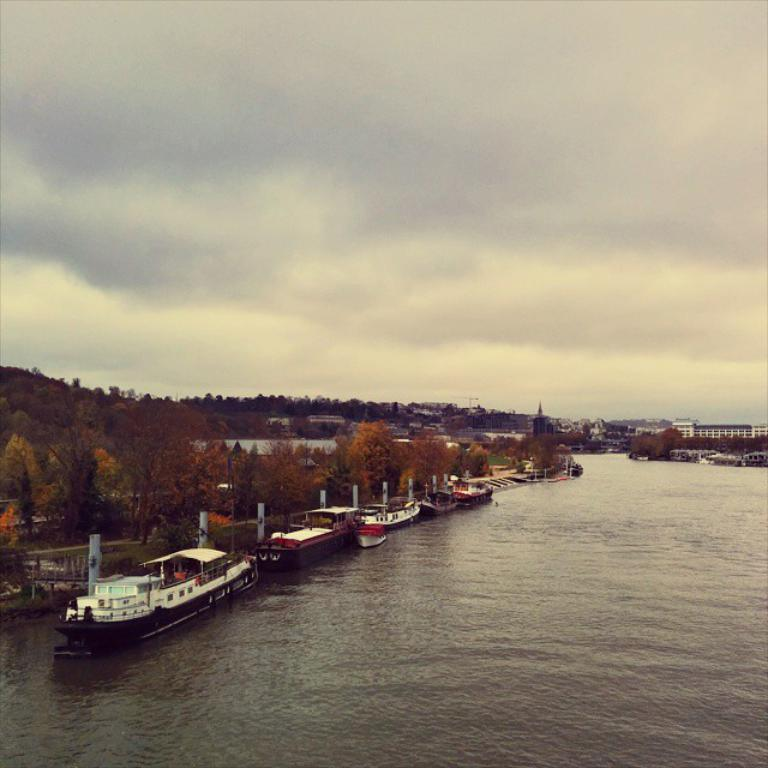What types of vehicles are in the image? There are ships and boats in the image. Where are the ships and boats located? The ships and boats are on the water. What can be seen in the background of the image? There are trees and buildings visible in the background of the image. What invention is being demonstrated by the passenger in the image? There is no passenger present in the image, and no invention is being demonstrated. 